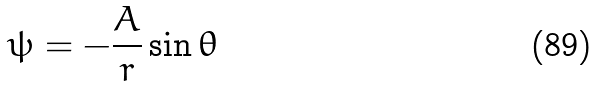<formula> <loc_0><loc_0><loc_500><loc_500>\psi = - \frac { A } { r } \sin \theta</formula> 